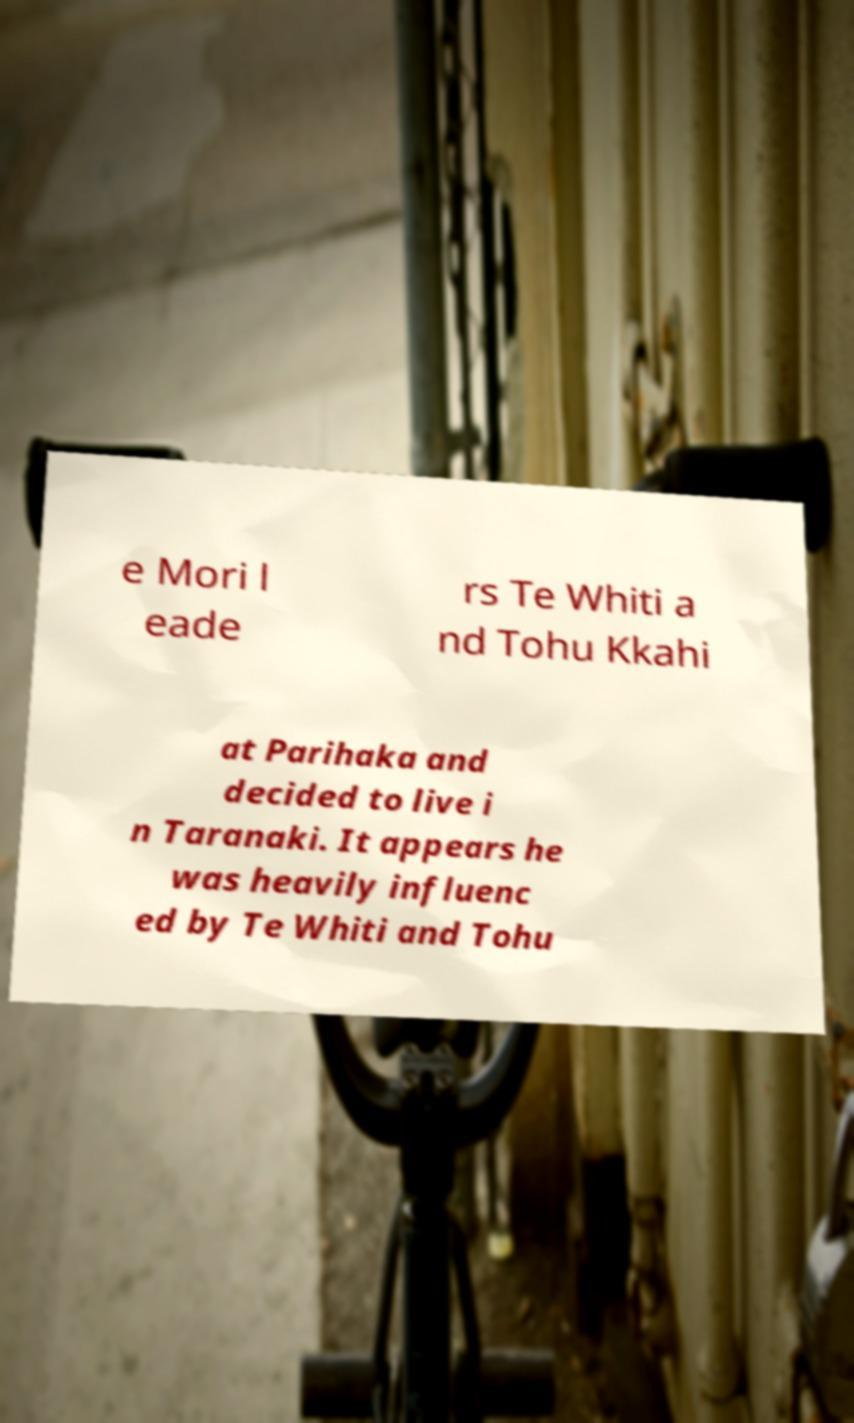Could you extract and type out the text from this image? e Mori l eade rs Te Whiti a nd Tohu Kkahi at Parihaka and decided to live i n Taranaki. It appears he was heavily influenc ed by Te Whiti and Tohu 